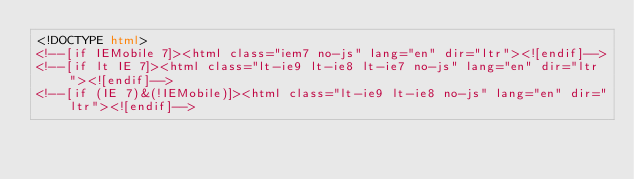<code> <loc_0><loc_0><loc_500><loc_500><_HTML_><!DOCTYPE html>
<!--[if IEMobile 7]><html class="iem7 no-js" lang="en" dir="ltr"><![endif]-->
<!--[if lt IE 7]><html class="lt-ie9 lt-ie8 lt-ie7 no-js" lang="en" dir="ltr"><![endif]-->
<!--[if (IE 7)&(!IEMobile)]><html class="lt-ie9 lt-ie8 no-js" lang="en" dir="ltr"><![endif]--></code> 